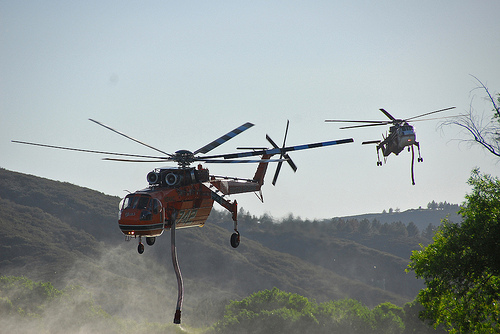<image>
Is the helicopter on the mountain? No. The helicopter is not positioned on the mountain. They may be near each other, but the helicopter is not supported by or resting on top of the mountain. Where is the hose in relation to the helicoptor? Is it under the helicoptor? Yes. The hose is positioned underneath the helicoptor, with the helicoptor above it in the vertical space. 